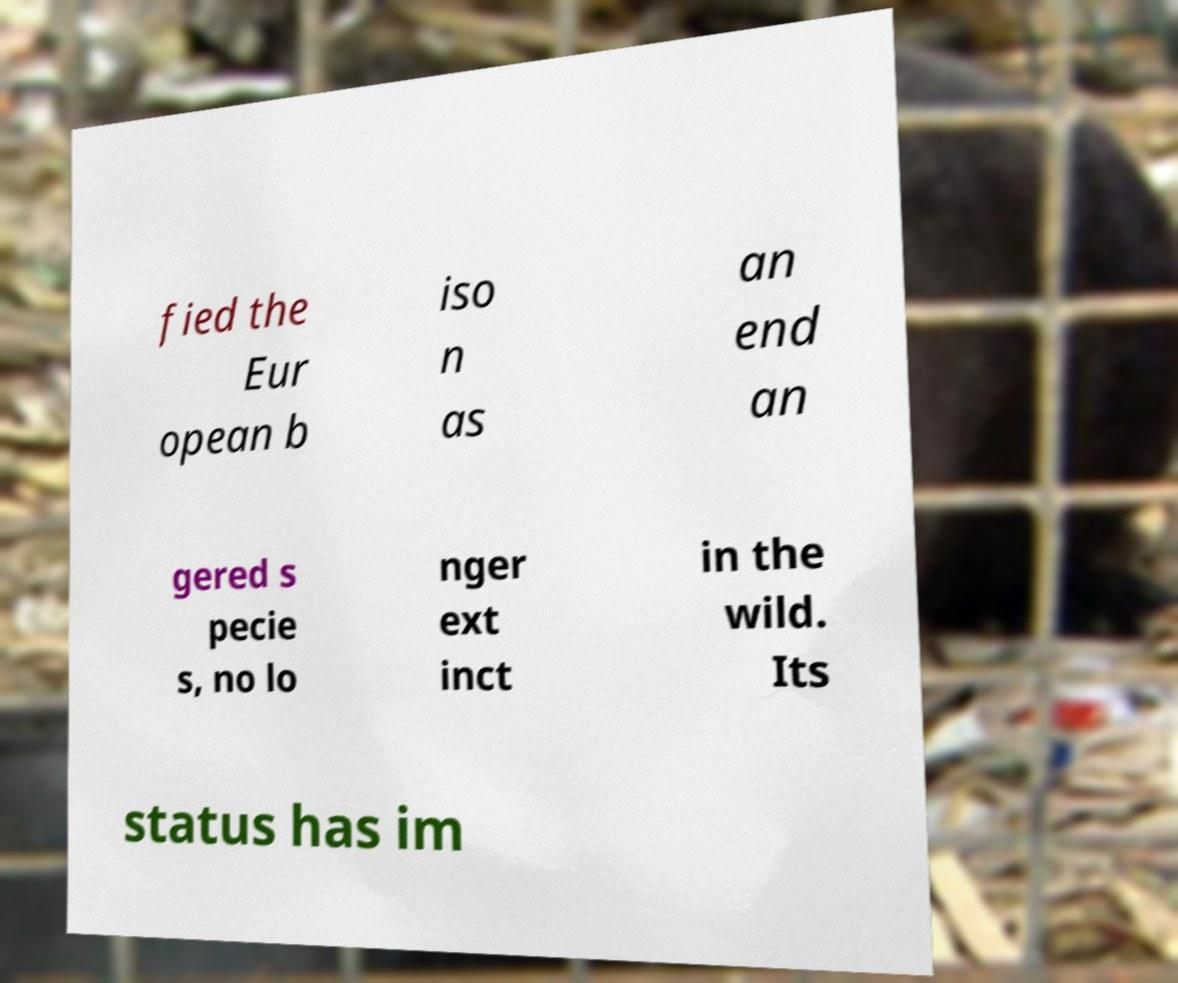For documentation purposes, I need the text within this image transcribed. Could you provide that? fied the Eur opean b iso n as an end an gered s pecie s, no lo nger ext inct in the wild. Its status has im 